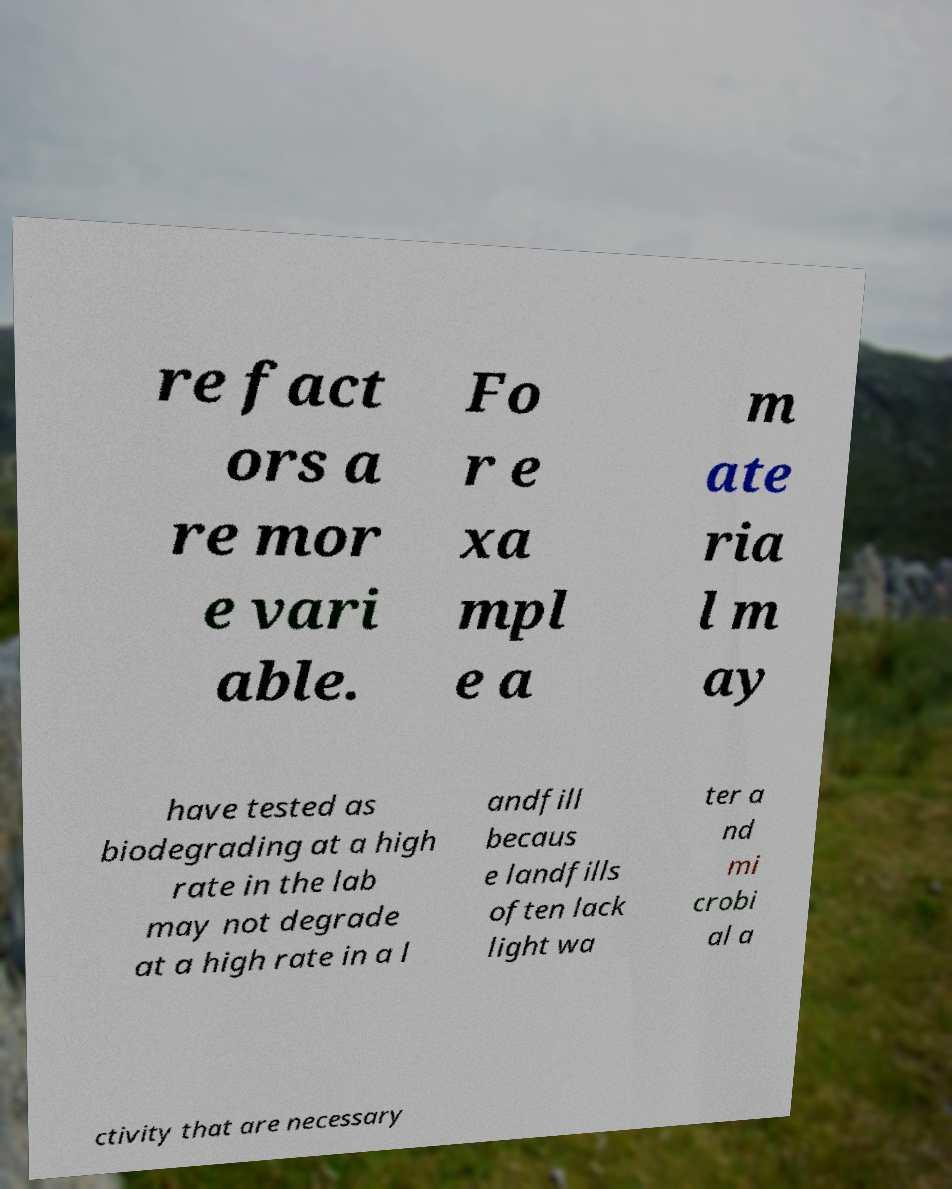Please identify and transcribe the text found in this image. re fact ors a re mor e vari able. Fo r e xa mpl e a m ate ria l m ay have tested as biodegrading at a high rate in the lab may not degrade at a high rate in a l andfill becaus e landfills often lack light wa ter a nd mi crobi al a ctivity that are necessary 